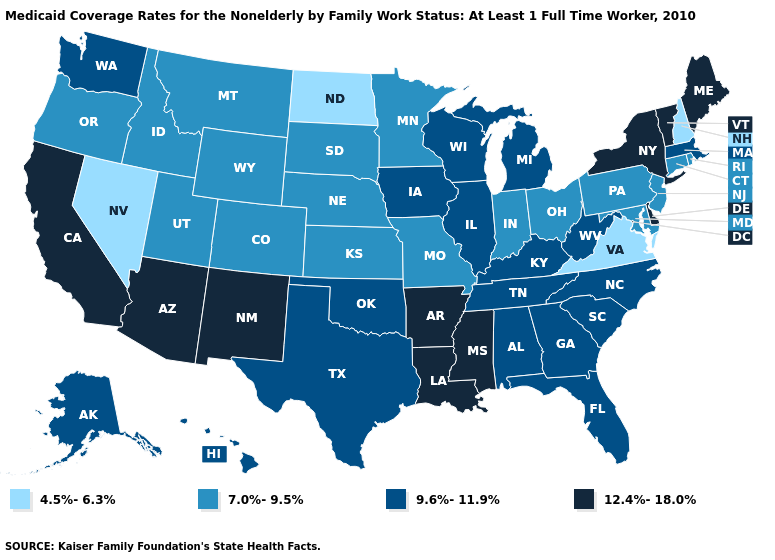Name the states that have a value in the range 12.4%-18.0%?
Keep it brief. Arizona, Arkansas, California, Delaware, Louisiana, Maine, Mississippi, New Mexico, New York, Vermont. Which states hav the highest value in the Northeast?
Answer briefly. Maine, New York, Vermont. What is the highest value in states that border Washington?
Quick response, please. 7.0%-9.5%. Does Idaho have the same value as Louisiana?
Give a very brief answer. No. Does Kansas have a higher value than Ohio?
Answer briefly. No. Does Vermont have a higher value than Louisiana?
Write a very short answer. No. What is the value of Louisiana?
Keep it brief. 12.4%-18.0%. Does Connecticut have a higher value than Florida?
Short answer required. No. What is the value of California?
Keep it brief. 12.4%-18.0%. What is the lowest value in the South?
Give a very brief answer. 4.5%-6.3%. Among the states that border New Jersey , does Pennsylvania have the highest value?
Answer briefly. No. Does New York have the highest value in the USA?
Quick response, please. Yes. Does Hawaii have a lower value than Indiana?
Keep it brief. No. What is the value of Louisiana?
Short answer required. 12.4%-18.0%. Does Nevada have the lowest value in the USA?
Be succinct. Yes. 